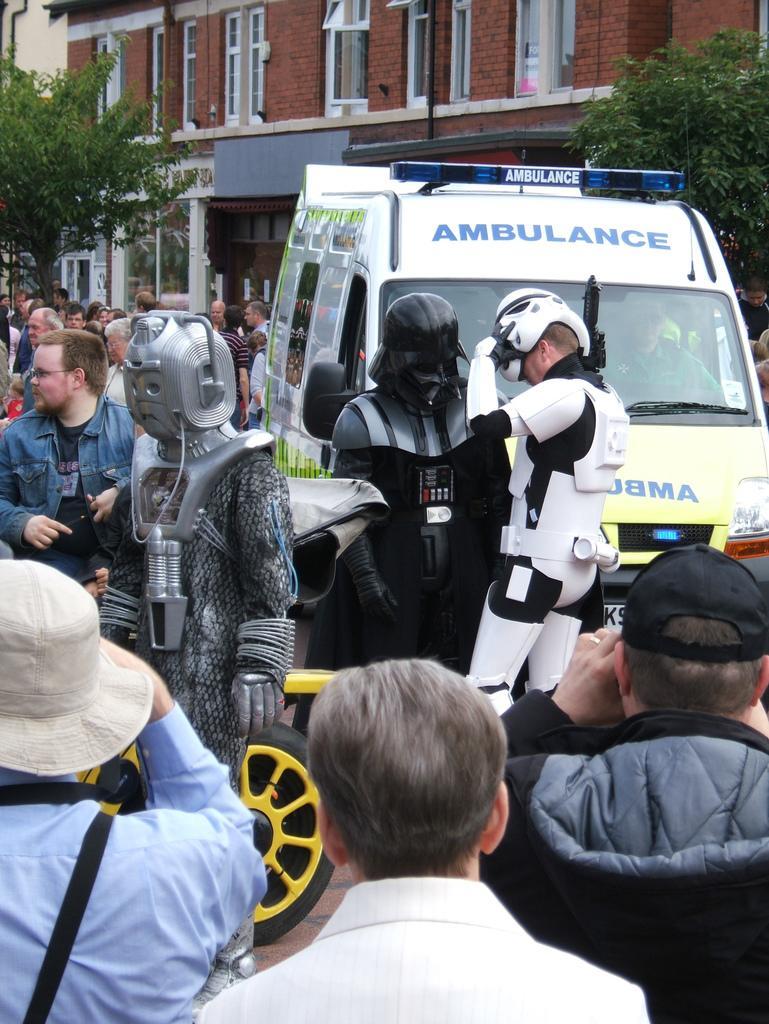How would you summarize this image in a sentence or two? This image is clicked on the road. There are many people standing on the road. There are a few people wearing costumes. To the right there is a van parked on the road. There is text on the van. On the either sides of the image there are trees. In the background there is a building. 